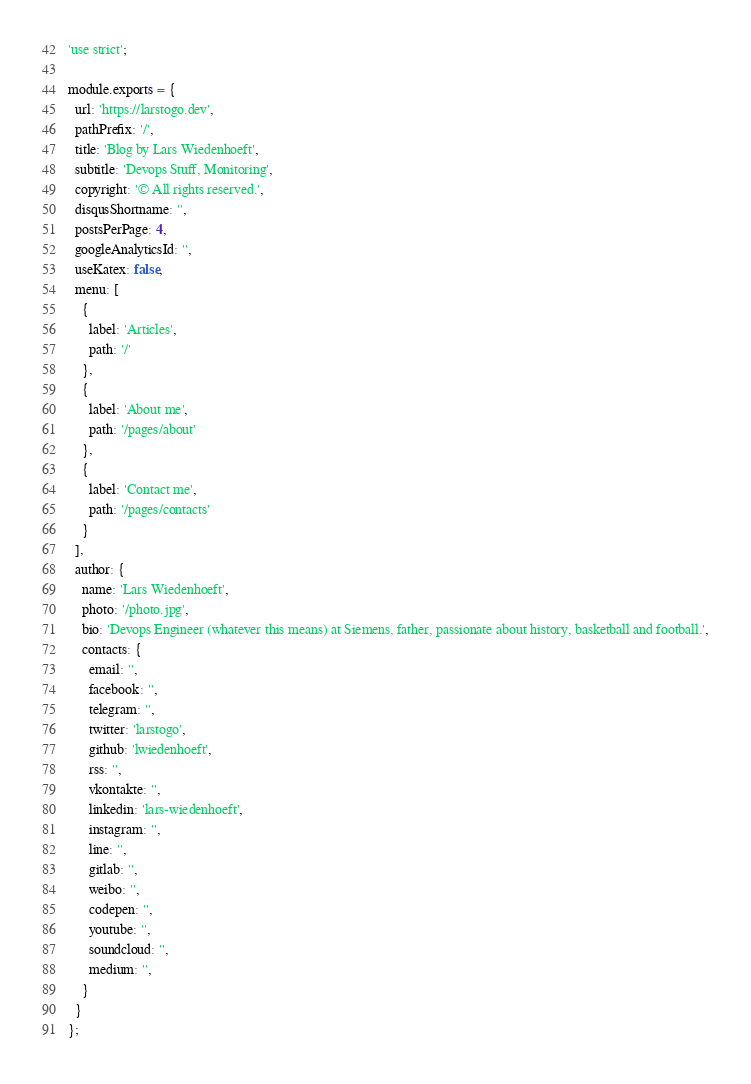Convert code to text. <code><loc_0><loc_0><loc_500><loc_500><_JavaScript_>'use strict';

module.exports = {
  url: 'https://larstogo.dev',
  pathPrefix: '/',
  title: 'Blog by Lars Wiedenhoeft',
  subtitle: 'Devops Stuff, Monitoring',
  copyright: '© All rights reserved.',
  disqusShortname: '',
  postsPerPage: 4,
  googleAnalyticsId: '',
  useKatex: false,
  menu: [
    {
      label: 'Articles',
      path: '/'
    },
    {
      label: 'About me',
      path: '/pages/about'
    },
    {
      label: 'Contact me',
      path: '/pages/contacts'
    }
  ],
  author: {
    name: 'Lars Wiedenhoeft',
    photo: '/photo.jpg',
    bio: 'Devops Engineer (whatever this means) at Siemens, father, passionate about history, basketball and football.',
    contacts: {
      email: '',
      facebook: '',
      telegram: '',
      twitter: 'larstogo',
      github: 'lwiedenhoeft',
      rss: '',
      vkontakte: '',
      linkedin: 'lars-wiedenhoeft',
      instagram: '',
      line: '',
      gitlab: '',
      weibo: '',
      codepen: '',
      youtube: '',
      soundcloud: '',
      medium: '',
    }
  }
};
</code> 